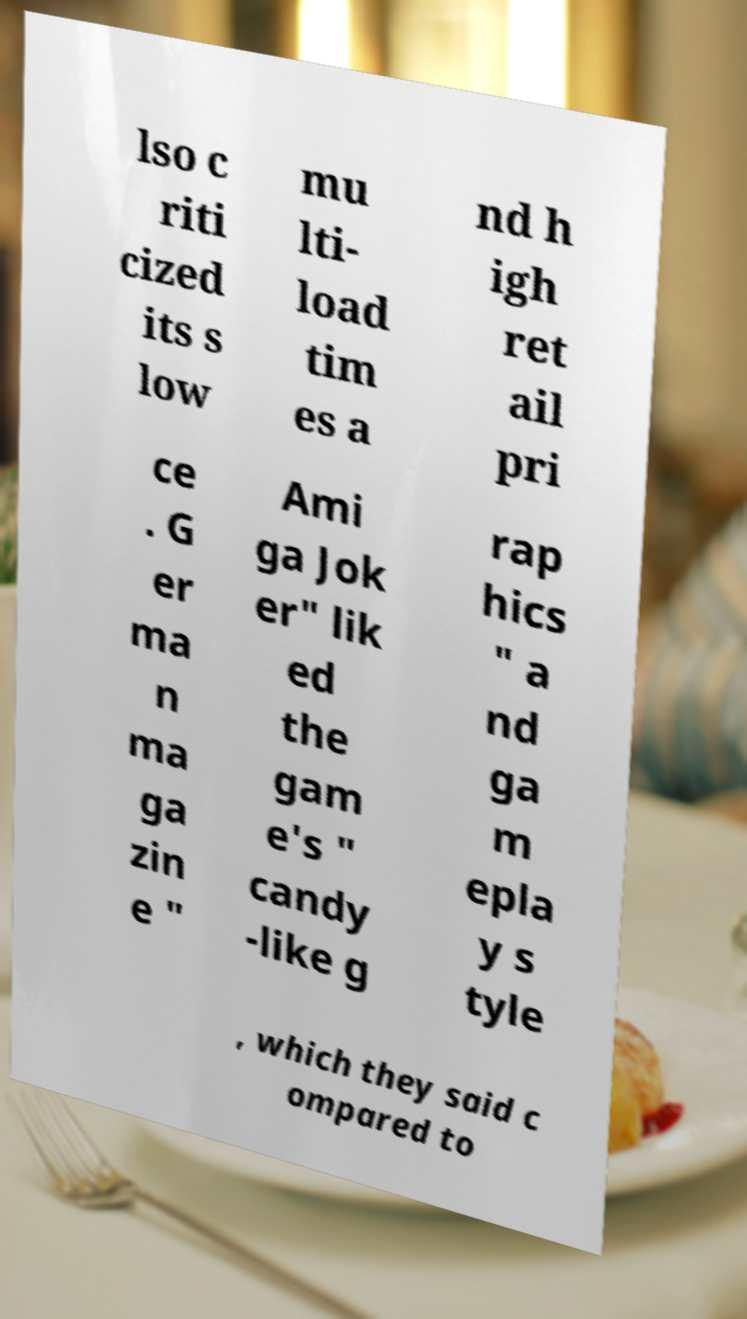For documentation purposes, I need the text within this image transcribed. Could you provide that? lso c riti cized its s low mu lti- load tim es a nd h igh ret ail pri ce . G er ma n ma ga zin e " Ami ga Jok er" lik ed the gam e's " candy -like g rap hics " a nd ga m epla y s tyle , which they said c ompared to 